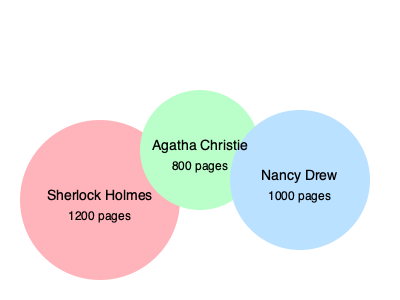Based on the bubble chart comparing the page counts of popular mystery series, which series has the highest total page count? To determine which series has the highest total page count, we need to compare the page counts provided in the bubble chart:

1. Sherlock Holmes: 1200 pages
2. Agatha Christie: 800 pages
3. Nancy Drew: 1000 pages

Comparing these numbers:
1200 > 1000 > 800

Therefore, the Sherlock Holmes series has the highest total page count among the three mystery series represented in the bubble chart.
Answer: Sherlock Holmes 